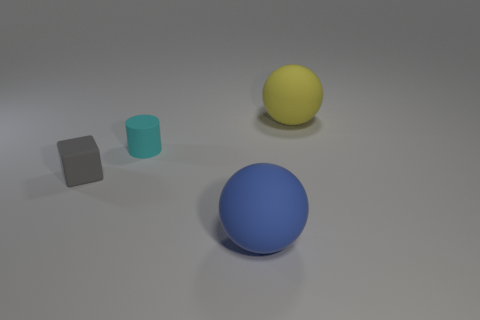Is the number of rubber cylinders behind the small gray matte cube greater than the number of small gray objects that are behind the tiny cyan cylinder?
Offer a terse response. Yes. There is a big sphere in front of the big object that is behind the small block; what is its color?
Make the answer very short. Blue. There is a cyan matte object that is behind the gray object behind the sphere that is left of the yellow rubber ball; what size is it?
Your answer should be very brief. Small. What shape is the tiny gray object?
Your answer should be very brief. Cube. How many cyan cylinders are behind the rubber object behind the cyan matte thing?
Offer a very short reply. 0. Is the large sphere to the right of the blue matte sphere made of the same material as the ball that is in front of the gray cube?
Your answer should be compact. Yes. Is there anything else that has the same shape as the big yellow object?
Make the answer very short. Yes. Is the cyan cylinder made of the same material as the big thing to the right of the blue rubber sphere?
Offer a terse response. Yes. What is the color of the big sphere that is behind the large rubber object in front of the big sphere that is behind the big blue thing?
Provide a short and direct response. Yellow. There is another matte thing that is the same size as the gray object; what is its shape?
Give a very brief answer. Cylinder. 